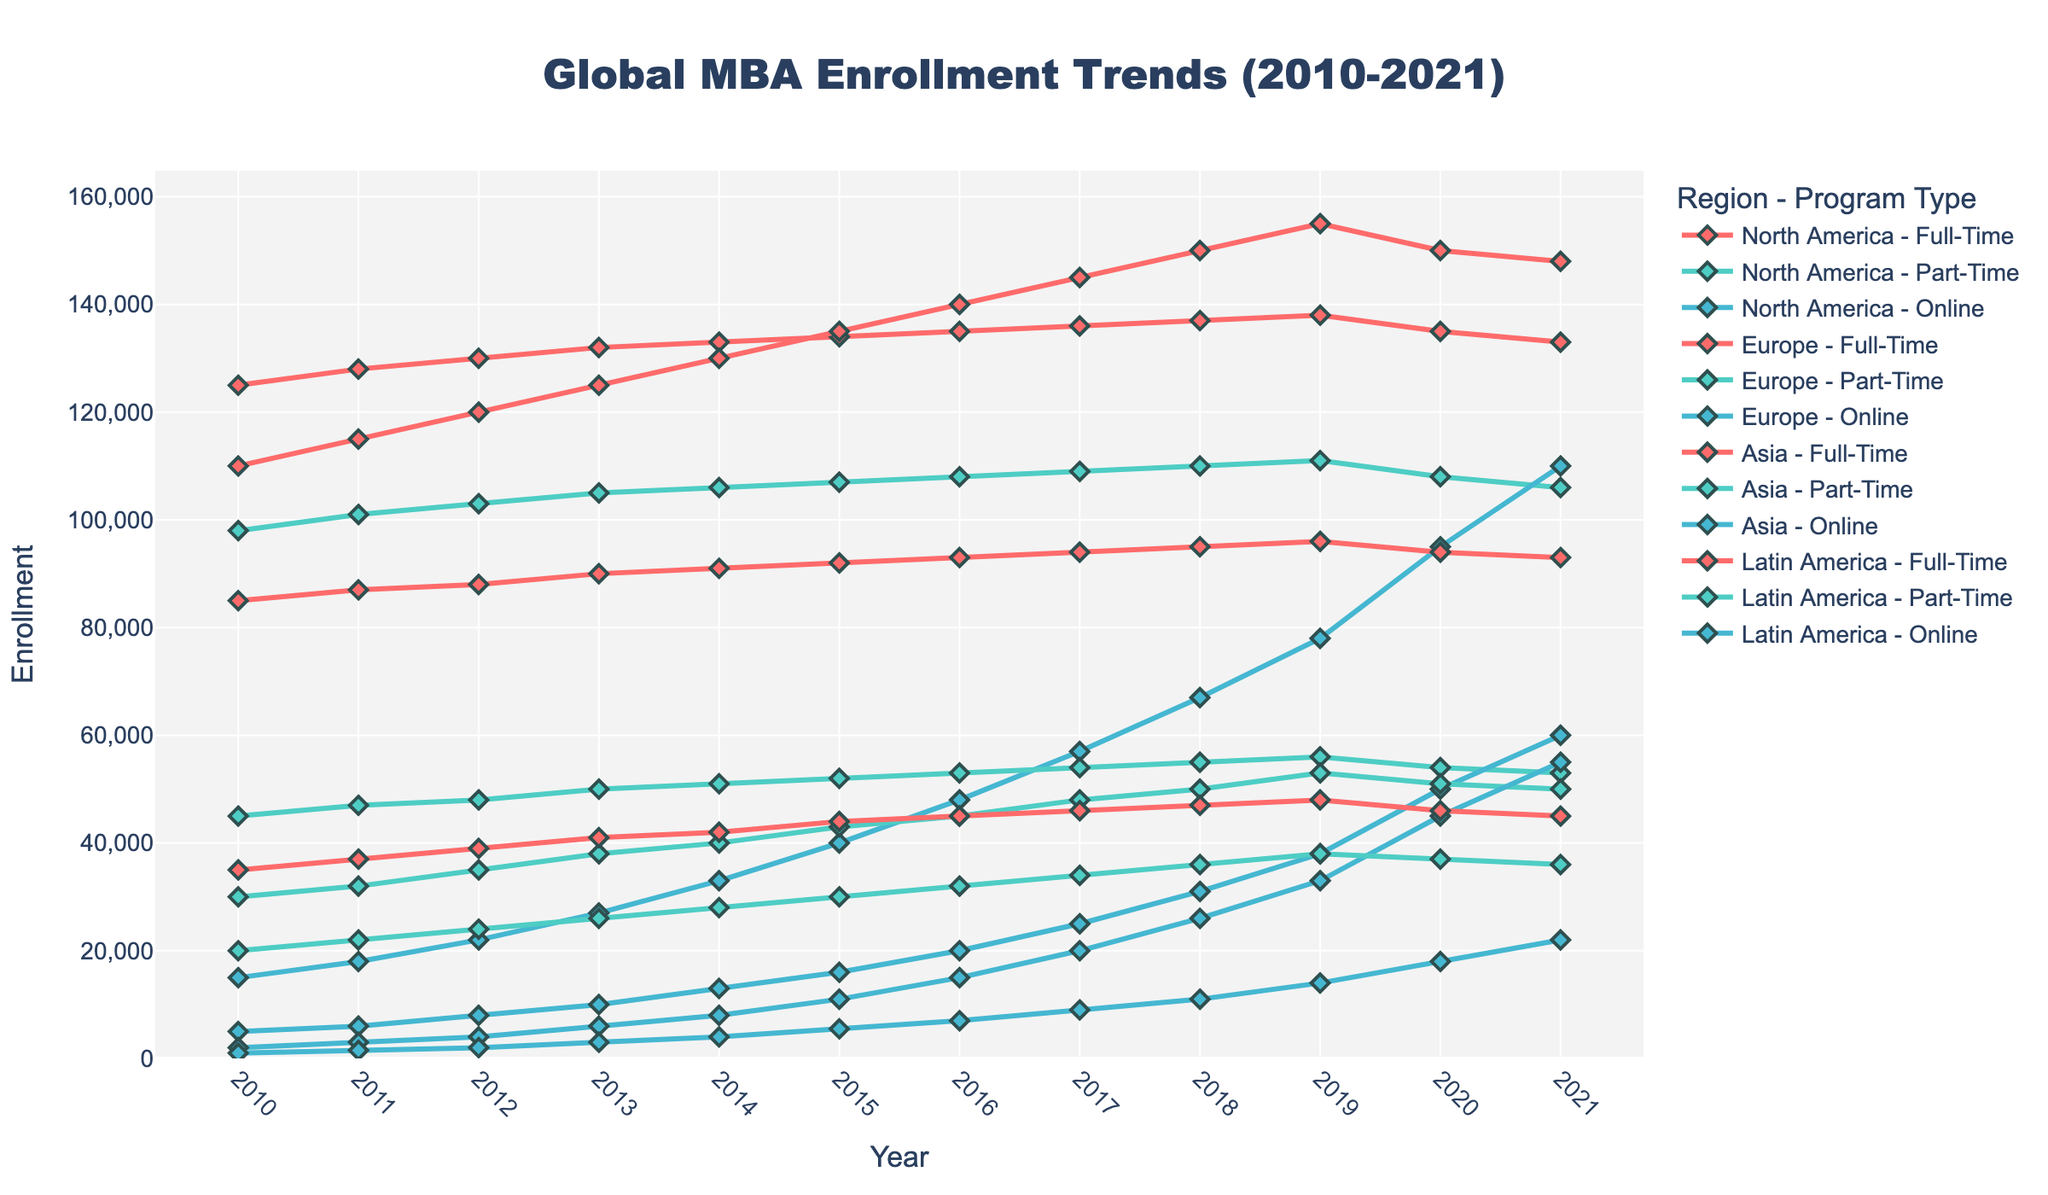Which region had the highest full-time MBA enrollment in 2021? By looking at the chart, we can identify the highest value among the full-time MBA enrollments. In 2021, Asia stands out with the highest full-time enrollment.
Answer: Asia How did North America's online MBA enrollment trend change from 2010 to 2021? To answer, we observe the line indicating North America's online MBA enrollment over the years. The trend shows a significant increase, starting at 15,000 in 2010 and reaching 110,000 by 2021.
Answer: Increased What was the difference in part-time MBA enrollment between North America and Europe in 2015? We find the values for North America and Europe part-time MBA enrollments in 2015. North America had 107,000, and Europe had 52,000. The difference is calculated as 107,000 - 52,000 = 55,000.
Answer: 55,000 Which region saw the most consistent growth in online MBA enrollments from 2010 to 2021? By examining the lines representing online MBA enrollments across all regions, Asia shows the most consistent growth, starting at 2,000 in 2010 and growing to 55,000 by 2021.
Answer: Asia In 2020, which region had a significant drop in full-time MBA enrollment compared to 2019, and by how much? Looking at the full-time MBA enrollment lines, North America experienced a drop from 138,000 in 2019 to 135,000 in 2020. The decrease is 138,000 - 135,000 = 3,000.
Answer: North America, 3,000 What is the average online MBA enrollment in Europe from 2010 to 2021? The values for Europe online MBA enrollments from 2010 to 2021 are summed up: 5,000 + 6,000 + 8,000 + 10,000 + 13,000 + 16,000 + 20,000 + 25,000 + 31,000 + 38,000 + 50,000 + 60,000 = 282,000. There are 12 data points, so the average is 282,000 / 12 = 23,500.
Answer: 23,500 Which region had the highest combined total MBA enrollments (full-time, part-time, and online) in 2014? We sum the full-time, part-time, and online enrollments for all regions in 2014. Asia: 130,000 + 40,000 + 8,000 = 178,000, North America: 133,000 + 106,000 + 33,000 = 272,000, Europe: 91,000 + 51,000 + 13,000 = 155,000, Latin America: 42,000 + 28,000 + 4,000 = 74,000. North America had the highest combined total.
Answer: North America Compare the gaps between full-time and part-time MBA enrollments in Latin America in 2010 and 2021. For 2010, Latin America's full-time enrollment was 35,000 and part-time was 20,000, giving a gap of 35,000 - 20,000 = 15,000. In 2021, full-time was 45,000 and part-time was 36,000, with a gap of 45,000 - 36,000 = 9,000.
Answer: 15,000 in 2010 and 9,000 in 2021 